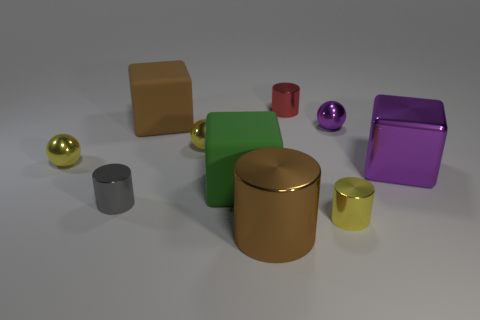Subtract 1 cylinders. How many cylinders are left? 3 Subtract all blocks. How many objects are left? 7 Add 1 large metal cubes. How many large metal cubes are left? 2 Add 3 big brown cylinders. How many big brown cylinders exist? 4 Subtract 0 green cylinders. How many objects are left? 10 Subtract all gray metallic objects. Subtract all purple metallic objects. How many objects are left? 7 